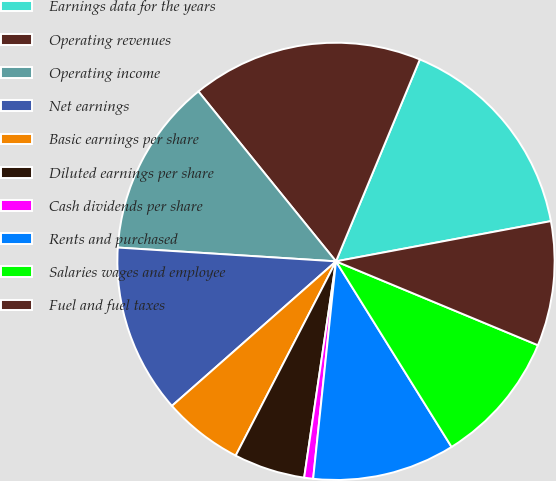Convert chart to OTSL. <chart><loc_0><loc_0><loc_500><loc_500><pie_chart><fcel>Earnings data for the years<fcel>Operating revenues<fcel>Operating income<fcel>Net earnings<fcel>Basic earnings per share<fcel>Diluted earnings per share<fcel>Cash dividends per share<fcel>Rents and purchased<fcel>Salaries wages and employee<fcel>Fuel and fuel taxes<nl><fcel>15.79%<fcel>17.1%<fcel>13.16%<fcel>12.5%<fcel>5.92%<fcel>5.26%<fcel>0.66%<fcel>10.53%<fcel>9.87%<fcel>9.21%<nl></chart> 